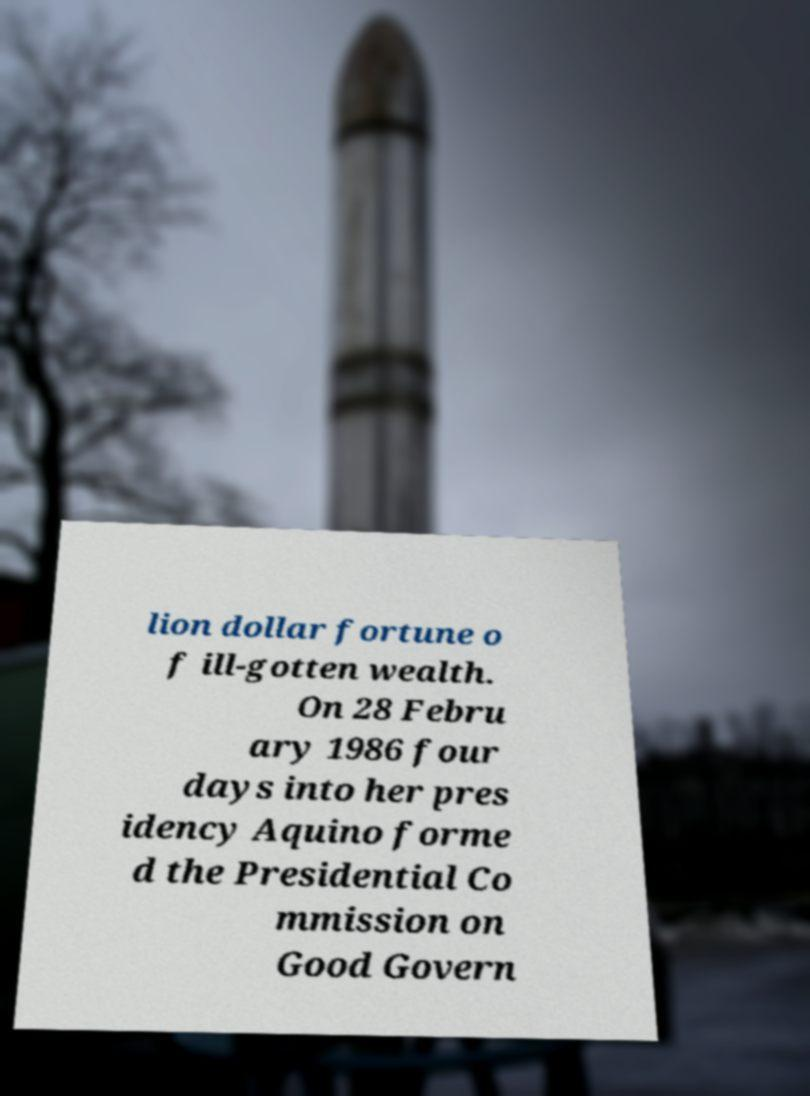For documentation purposes, I need the text within this image transcribed. Could you provide that? lion dollar fortune o f ill-gotten wealth. On 28 Febru ary 1986 four days into her pres idency Aquino forme d the Presidential Co mmission on Good Govern 